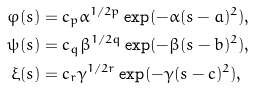<formula> <loc_0><loc_0><loc_500><loc_500>\varphi ( s ) & = c _ { p } \alpha ^ { 1 / 2 p } \exp ( - \alpha ( s - a ) ^ { 2 } ) , \\ \psi ( s ) & = c _ { q } \beta ^ { 1 / 2 q } \exp ( - \beta ( s - b ) ^ { 2 } ) , \\ \xi ( s ) & = c _ { r } \gamma ^ { 1 / 2 r } \exp ( - \gamma ( s - c ) ^ { 2 } ) ,</formula> 